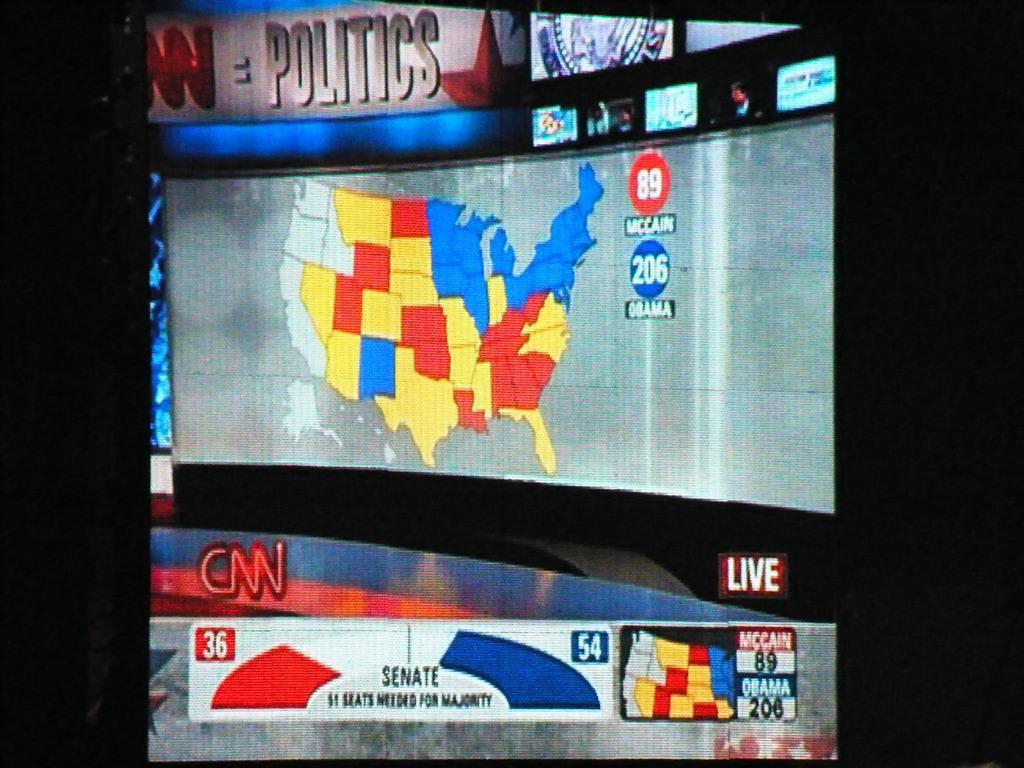<image>
Render a clear and concise summary of the photo. a news report on a television monitor for CNN live that shows a map of the united states for voting 